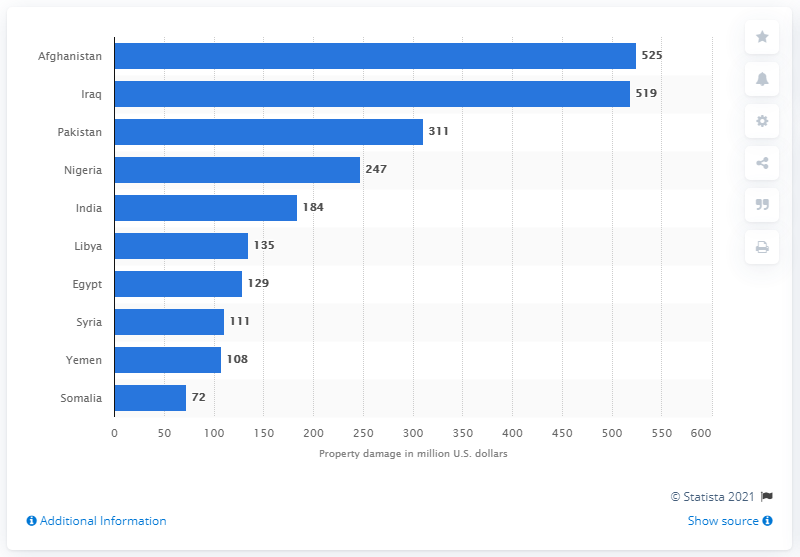Specify some key components in this picture. In 2015, the property in Afghanistan suffered damages worth $525 million due to terrorism. 